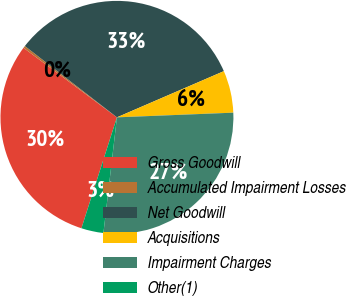<chart> <loc_0><loc_0><loc_500><loc_500><pie_chart><fcel>Gross Goodwill<fcel>Accumulated Impairment Losses<fcel>Net Goodwill<fcel>Acquisitions<fcel>Impairment Charges<fcel>Other(1)<nl><fcel>30.25%<fcel>0.31%<fcel>33.02%<fcel>5.85%<fcel>27.49%<fcel>3.08%<nl></chart> 